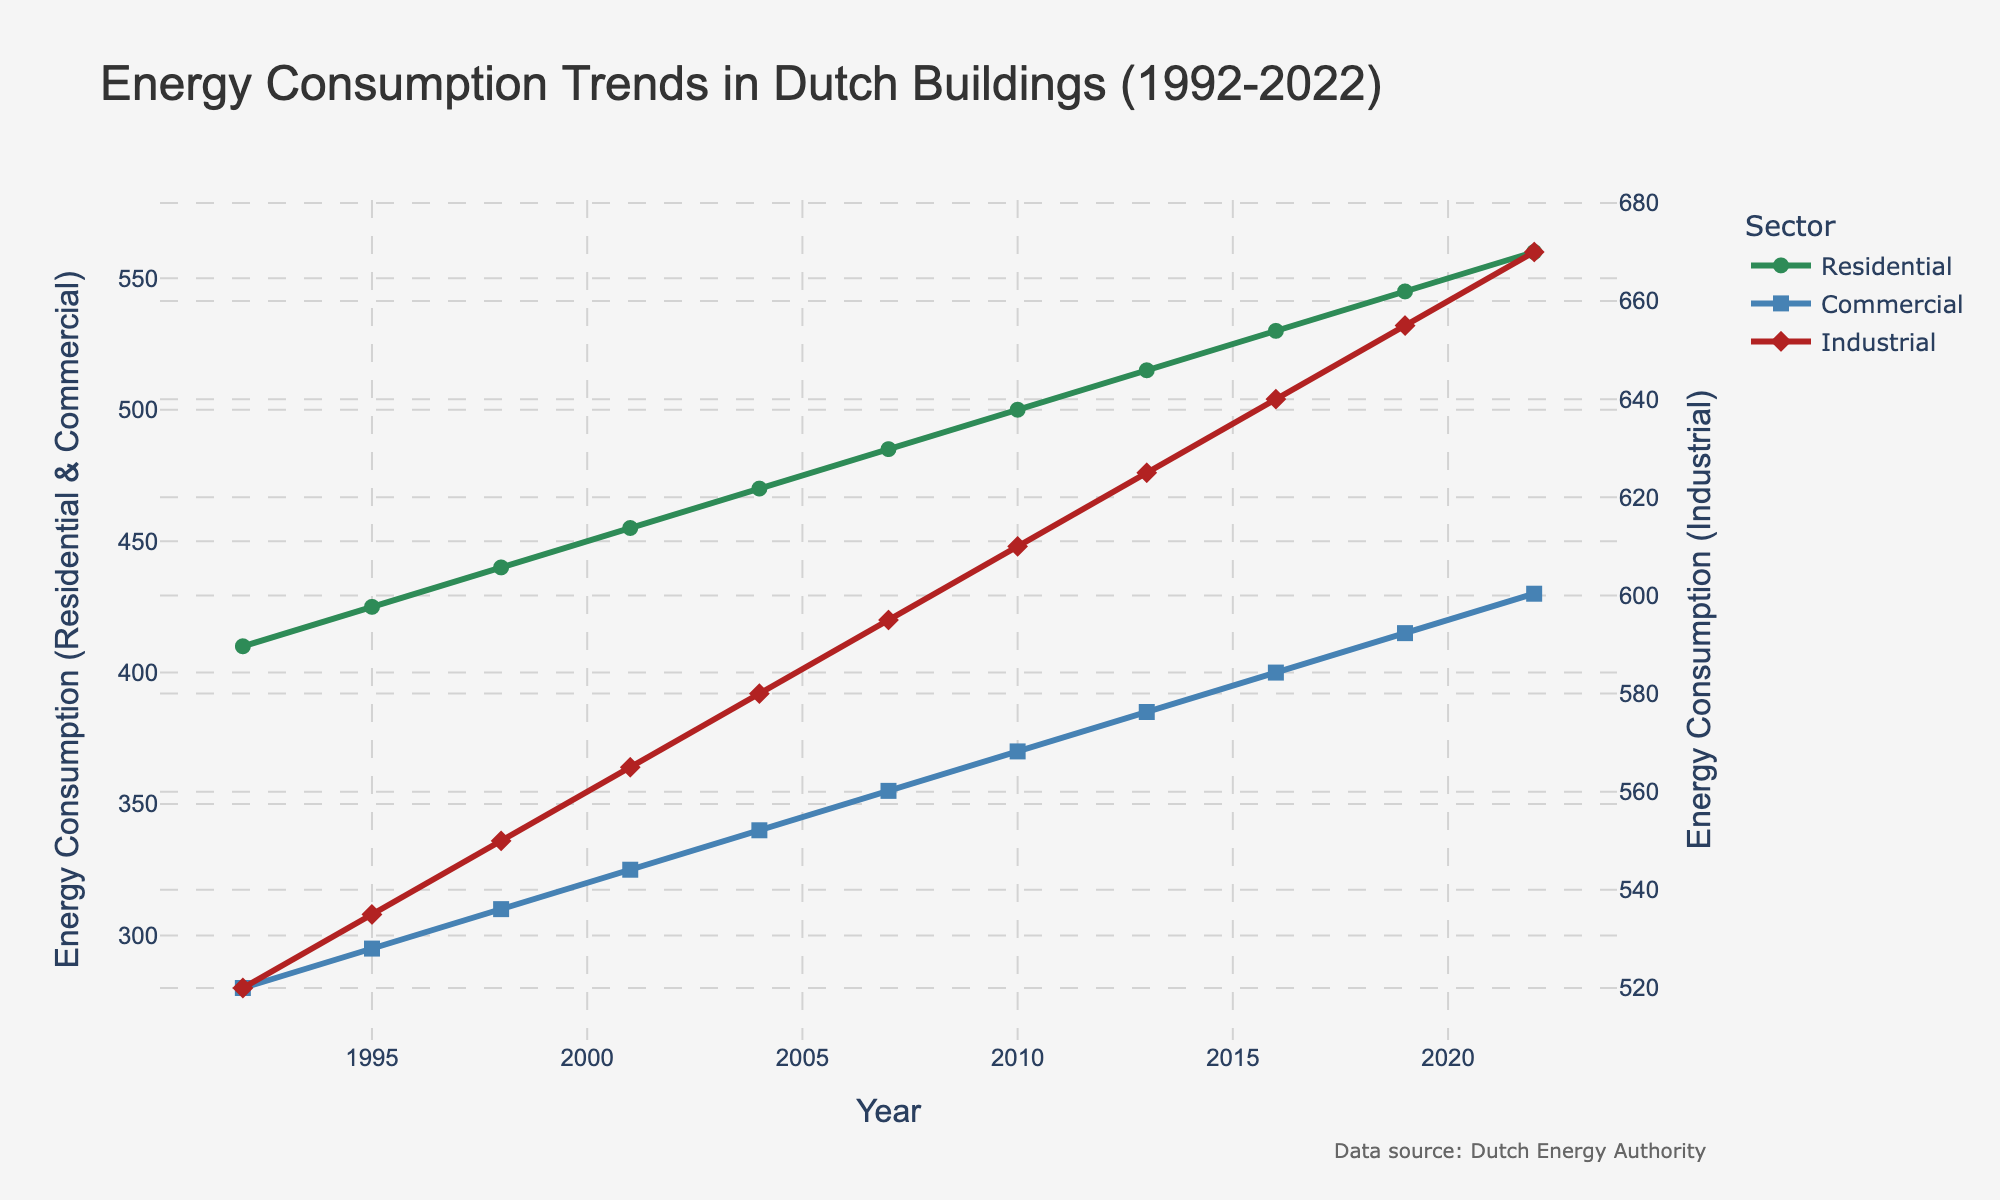What trends can you observe in the residential energy consumption over the past 30 years? The residential energy consumption shows a steady increase from 410 units in 1992 to 560 units in 2022. Each successive data point is consistently higher than the previous one, indicating continuous growth.
Answer: Steady increase Which sector had the highest energy consumption in 2010? In 2010, the industrial sector had the highest energy consumption at 610 units, compared to 500 units in the residential sector and 370 units in the commercial sector.
Answer: Industrial What was the percentage increase in commercial energy consumption from 1992 to 2022? The commercial sector's energy consumption increased from 280 units in 1992 to 430 units in 2022. The percentage increase is calculated as ((430 - 280) / 280) * 100.
Answer: 53.57% Compare the growth rates of residential and industrial energy consumption from 1992 to 2022. Which grew faster? Residential consumption grew from 410 to 560 units, an increase of 150 units. Industrial grew from 520 to 670 units, an increase of 150 units. The percentage increase for residential is ((560 - 410) / 410) * 100 ≈ 36.59%, and for industrial is ((670 - 520) / 520) * 100 ≈ 28.85%. Therefore, residential grew faster in percentage terms.
Answer: Residential What is the average energy consumption of the commercial sector over the 30 years? Add up the commercial energy consumption values: (280 + 295 + 310 + 325 + 340 + 355 + 370 + 385 + 400 + 415 + 430) = 4,305 units. Divide by the number of years (11), resulting in 4305 / 11 ≈ 391.36 units.
Answer: 391.36 Which year saw the greatest increase in industrial energy consumption compared to the previous data point? The increase is calculated for each interval: 1992-1995 (535-520)=15, 1995-1998 (550-535)=15, 1998-2001 (565-550)=15, 2001-2004 (580-565)=15, 2004-2007 (595-580)=15, 2007-2010 (610-595)=15, 2010-2013 (625-610)=15, 2013-2016 (640-625)=15, 2016-2019 (655-640)=15, 2019-2022 (670-655)=15. All intervals show a consistent increase; hence no greatest increase stands out.
Answer: Consistent increase Which sector had the smallest energy consumption increment in a single 3-year period, and when? To find the smallest increment, calculate the differences for each period: Residential (1992-1995=15, 1995-1998=15, etc.), Commercial (1992-1995=15, etc.), Industrial (1992-1995=15, etc.). All sectors reported consistent increments of 15 units for all periods.
Answer: All increments equal Can you identify any visual patterns or trends specifically related to the colors of the lines representing each sector? The residential sector, depicted in green, starts low and consistently increases. The commercial sector, in blue, follows a similar steady increase but starts lower than residential. The industrial sector, in red, starts higher and also steadily climbs.
Answer: Steady increase for all sectors 